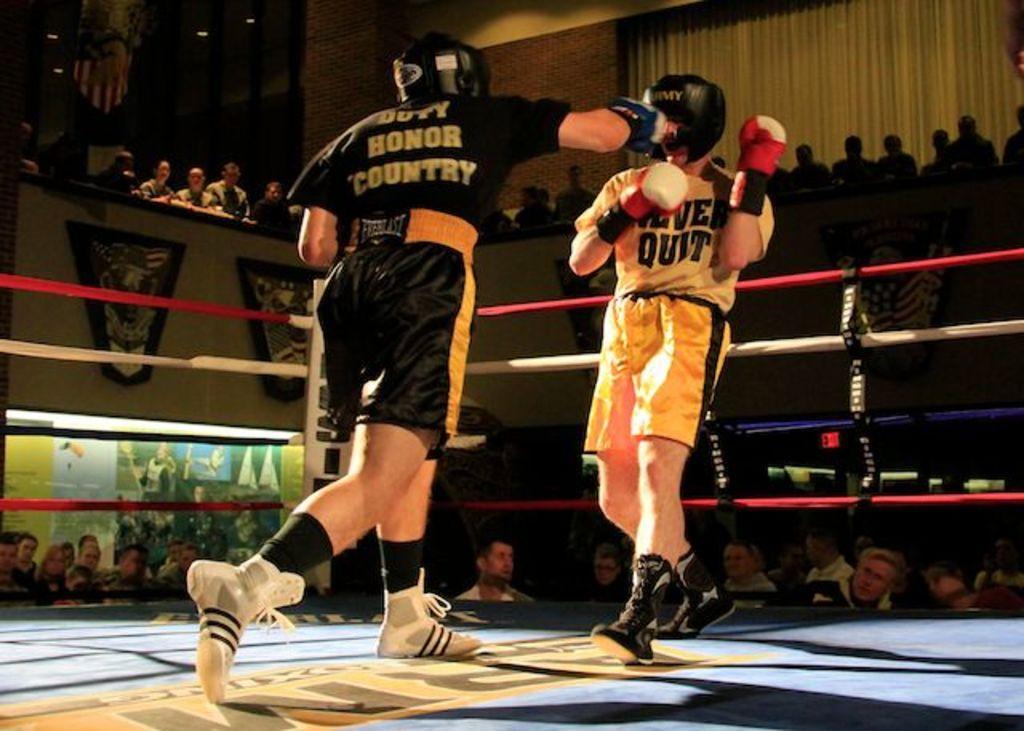Please provide a concise description of this image. In this image we can see two persons wearing black and yellow color dress respectively playing boxing and at the background of the image there are some spectators standing, sitting and there is wall. 